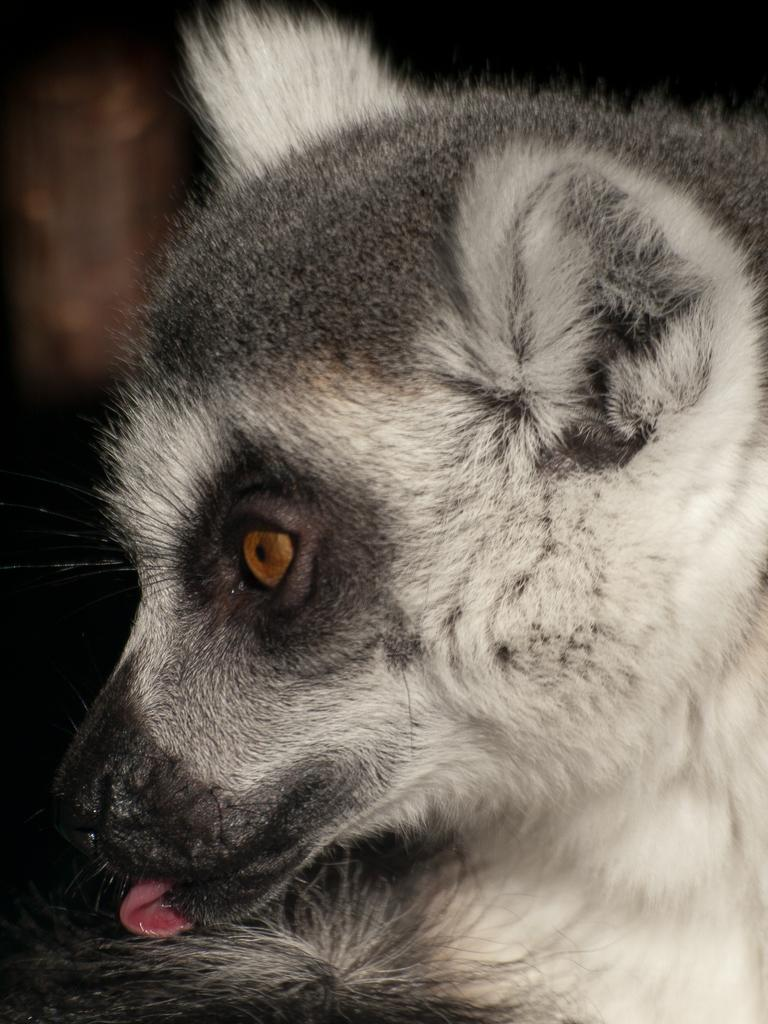What type of creature is in the picture? There is an animal in the picture. In which direction is the animal looking? The animal is looking to the left. What colors can be seen in the animal's fur? The animal has white and black fur. What is the color of the background in the image? The backdrop of the image is dark. What type of crack can be seen in the animal's fur? There is no crack present in the animal's fur; it has a smooth texture. What color is the orange in the image? There is no orange present in the image. 